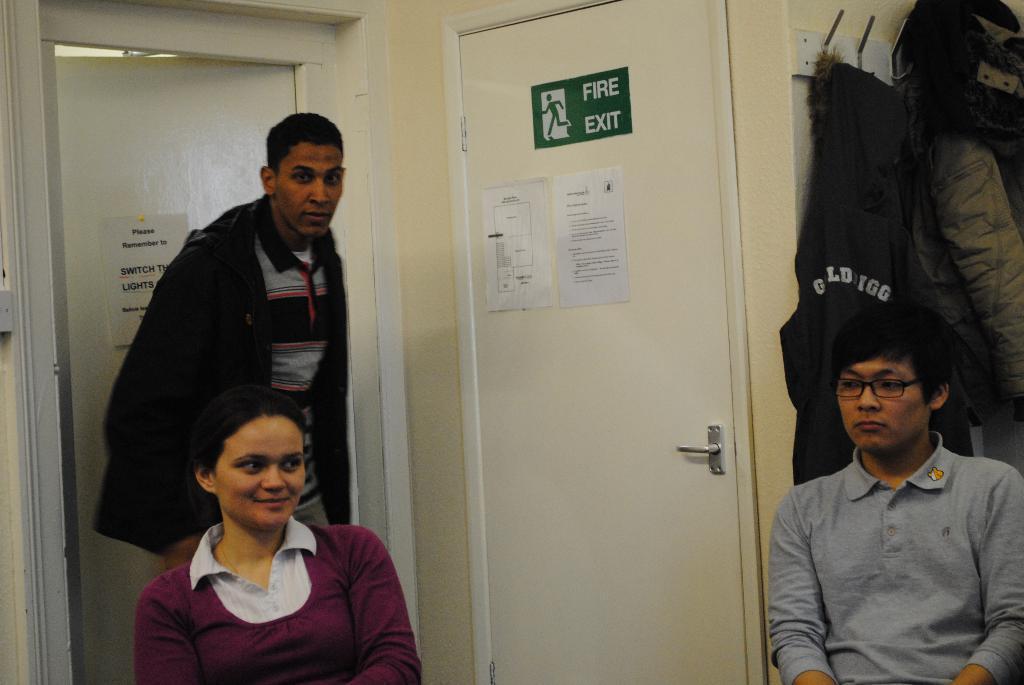In one or two sentences, can you explain what this image depicts? This image consists of three persons in a room. In the background, there are two doors. On the right, there are coats hanged. And we can see the papers on the door. 